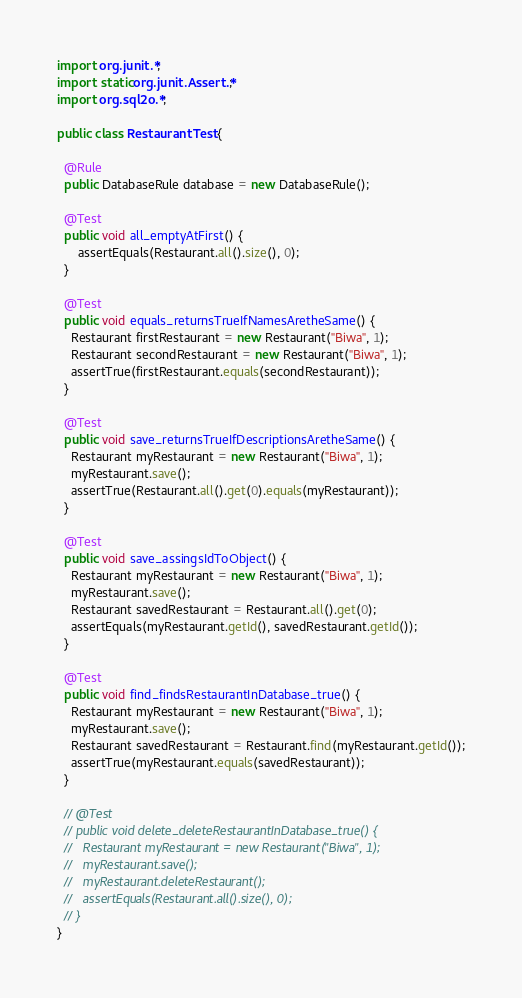<code> <loc_0><loc_0><loc_500><loc_500><_Java_>import org.junit.*;
import static org.junit.Assert.*;
import org.sql2o.*;

public class RestaurantTest {

  @Rule
  public DatabaseRule database = new DatabaseRule();

  @Test
  public void all_emptyAtFirst() {
      assertEquals(Restaurant.all().size(), 0);
  }

  @Test
  public void equals_returnsTrueIfNamesAretheSame() {
    Restaurant firstRestaurant = new Restaurant("Biwa", 1);
    Restaurant secondRestaurant = new Restaurant("Biwa", 1);
    assertTrue(firstRestaurant.equals(secondRestaurant));
  }

  @Test
  public void save_returnsTrueIfDescriptionsAretheSame() {
    Restaurant myRestaurant = new Restaurant("Biwa", 1);
    myRestaurant.save();
    assertTrue(Restaurant.all().get(0).equals(myRestaurant));
  }

  @Test
  public void save_assingsIdToObject() {
    Restaurant myRestaurant = new Restaurant("Biwa", 1);
    myRestaurant.save();
    Restaurant savedRestaurant = Restaurant.all().get(0);
    assertEquals(myRestaurant.getId(), savedRestaurant.getId());
  }

  @Test
  public void find_findsRestaurantInDatabase_true() {
    Restaurant myRestaurant = new Restaurant("Biwa", 1);
    myRestaurant.save();
    Restaurant savedRestaurant = Restaurant.find(myRestaurant.getId());
    assertTrue(myRestaurant.equals(savedRestaurant));
  }

  // @Test
  // public void delete_deleteRestaurantInDatabase_true() {
  //   Restaurant myRestaurant = new Restaurant("Biwa", 1);
  //   myRestaurant.save();
  //   myRestaurant.deleteRestaurant();
  //   assertEquals(Restaurant.all().size(), 0);
  // }
}
</code> 